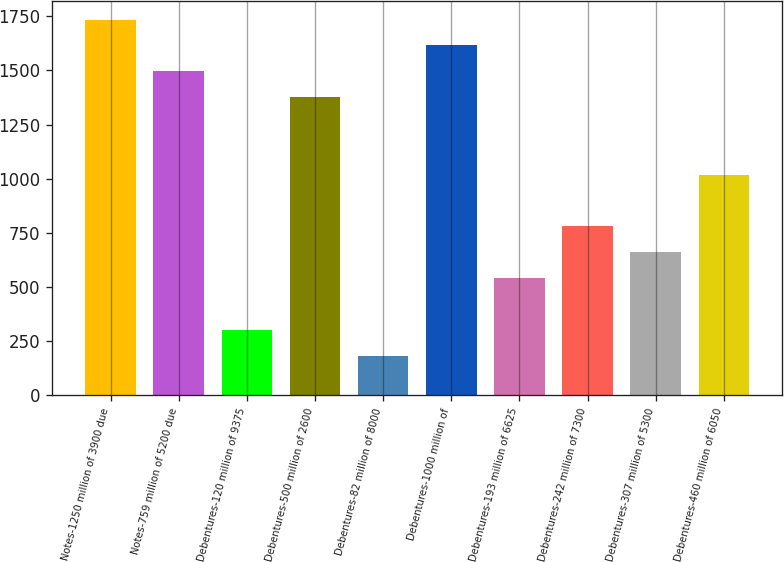Convert chart to OTSL. <chart><loc_0><loc_0><loc_500><loc_500><bar_chart><fcel>Notes-1250 million of 3900 due<fcel>Notes-759 million of 5200 due<fcel>Debentures-120 million of 9375<fcel>Debentures-500 million of 2600<fcel>Debentures-82 million of 8000<fcel>Debentures-1000 million of<fcel>Debentures-193 million of 6625<fcel>Debentures-242 million of 7300<fcel>Debentures-307 million of 5300<fcel>Debentures-460 million of 6050<nl><fcel>1734.2<fcel>1495.6<fcel>302.6<fcel>1376.3<fcel>183.3<fcel>1614.9<fcel>541.2<fcel>779.8<fcel>660.5<fcel>1018.4<nl></chart> 